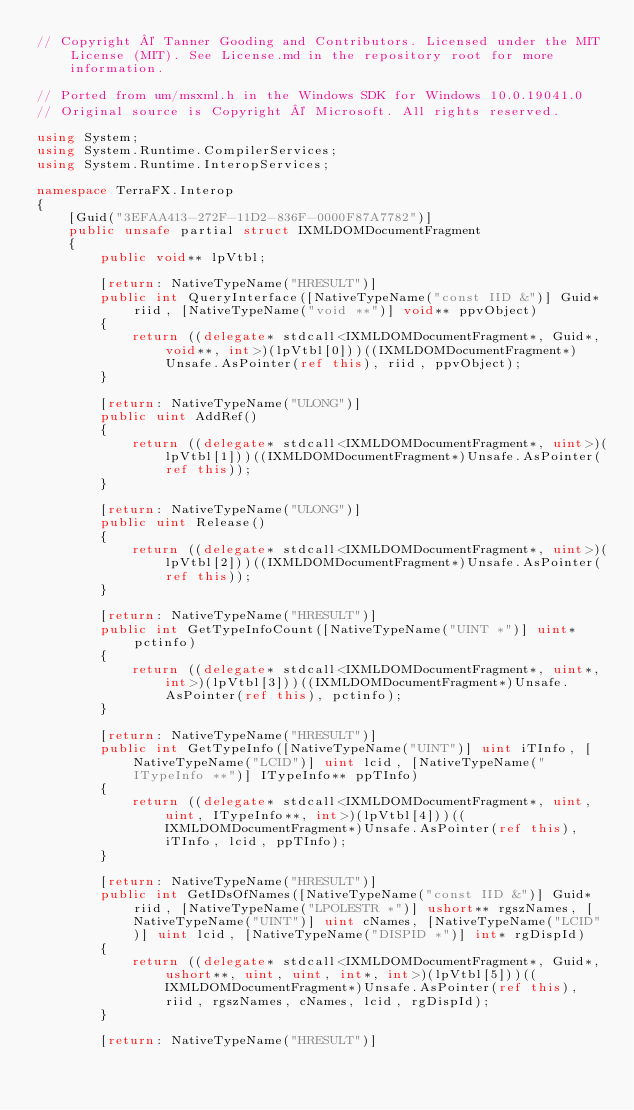<code> <loc_0><loc_0><loc_500><loc_500><_C#_>// Copyright © Tanner Gooding and Contributors. Licensed under the MIT License (MIT). See License.md in the repository root for more information.

// Ported from um/msxml.h in the Windows SDK for Windows 10.0.19041.0
// Original source is Copyright © Microsoft. All rights reserved.

using System;
using System.Runtime.CompilerServices;
using System.Runtime.InteropServices;

namespace TerraFX.Interop
{
    [Guid("3EFAA413-272F-11D2-836F-0000F87A7782")]
    public unsafe partial struct IXMLDOMDocumentFragment
    {
        public void** lpVtbl;

        [return: NativeTypeName("HRESULT")]
        public int QueryInterface([NativeTypeName("const IID &")] Guid* riid, [NativeTypeName("void **")] void** ppvObject)
        {
            return ((delegate* stdcall<IXMLDOMDocumentFragment*, Guid*, void**, int>)(lpVtbl[0]))((IXMLDOMDocumentFragment*)Unsafe.AsPointer(ref this), riid, ppvObject);
        }

        [return: NativeTypeName("ULONG")]
        public uint AddRef()
        {
            return ((delegate* stdcall<IXMLDOMDocumentFragment*, uint>)(lpVtbl[1]))((IXMLDOMDocumentFragment*)Unsafe.AsPointer(ref this));
        }

        [return: NativeTypeName("ULONG")]
        public uint Release()
        {
            return ((delegate* stdcall<IXMLDOMDocumentFragment*, uint>)(lpVtbl[2]))((IXMLDOMDocumentFragment*)Unsafe.AsPointer(ref this));
        }

        [return: NativeTypeName("HRESULT")]
        public int GetTypeInfoCount([NativeTypeName("UINT *")] uint* pctinfo)
        {
            return ((delegate* stdcall<IXMLDOMDocumentFragment*, uint*, int>)(lpVtbl[3]))((IXMLDOMDocumentFragment*)Unsafe.AsPointer(ref this), pctinfo);
        }

        [return: NativeTypeName("HRESULT")]
        public int GetTypeInfo([NativeTypeName("UINT")] uint iTInfo, [NativeTypeName("LCID")] uint lcid, [NativeTypeName("ITypeInfo **")] ITypeInfo** ppTInfo)
        {
            return ((delegate* stdcall<IXMLDOMDocumentFragment*, uint, uint, ITypeInfo**, int>)(lpVtbl[4]))((IXMLDOMDocumentFragment*)Unsafe.AsPointer(ref this), iTInfo, lcid, ppTInfo);
        }

        [return: NativeTypeName("HRESULT")]
        public int GetIDsOfNames([NativeTypeName("const IID &")] Guid* riid, [NativeTypeName("LPOLESTR *")] ushort** rgszNames, [NativeTypeName("UINT")] uint cNames, [NativeTypeName("LCID")] uint lcid, [NativeTypeName("DISPID *")] int* rgDispId)
        {
            return ((delegate* stdcall<IXMLDOMDocumentFragment*, Guid*, ushort**, uint, uint, int*, int>)(lpVtbl[5]))((IXMLDOMDocumentFragment*)Unsafe.AsPointer(ref this), riid, rgszNames, cNames, lcid, rgDispId);
        }

        [return: NativeTypeName("HRESULT")]</code> 